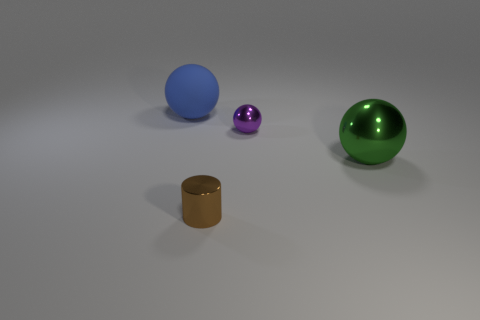What number of purple balls have the same size as the purple object?
Offer a terse response. 0. How many things are green spheres or things to the right of the large rubber thing?
Ensure brevity in your answer.  3. The matte object is what shape?
Provide a short and direct response. Sphere. Does the matte thing have the same color as the small sphere?
Ensure brevity in your answer.  No. There is a rubber ball that is the same size as the green thing; what color is it?
Give a very brief answer. Blue. How many brown objects are either large shiny spheres or balls?
Keep it short and to the point. 0. Are there more big matte things than large things?
Your answer should be very brief. No. There is a metal thing behind the large metal sphere; does it have the same size as the thing that is on the right side of the purple shiny ball?
Your answer should be compact. No. There is a object that is in front of the large ball that is in front of the shiny sphere that is to the left of the big metal object; what is its color?
Provide a short and direct response. Brown. Are there any large objects that have the same shape as the tiny purple shiny object?
Provide a short and direct response. Yes. 